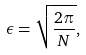Convert formula to latex. <formula><loc_0><loc_0><loc_500><loc_500>\epsilon = \sqrt { \frac { 2 \pi } N } ,</formula> 